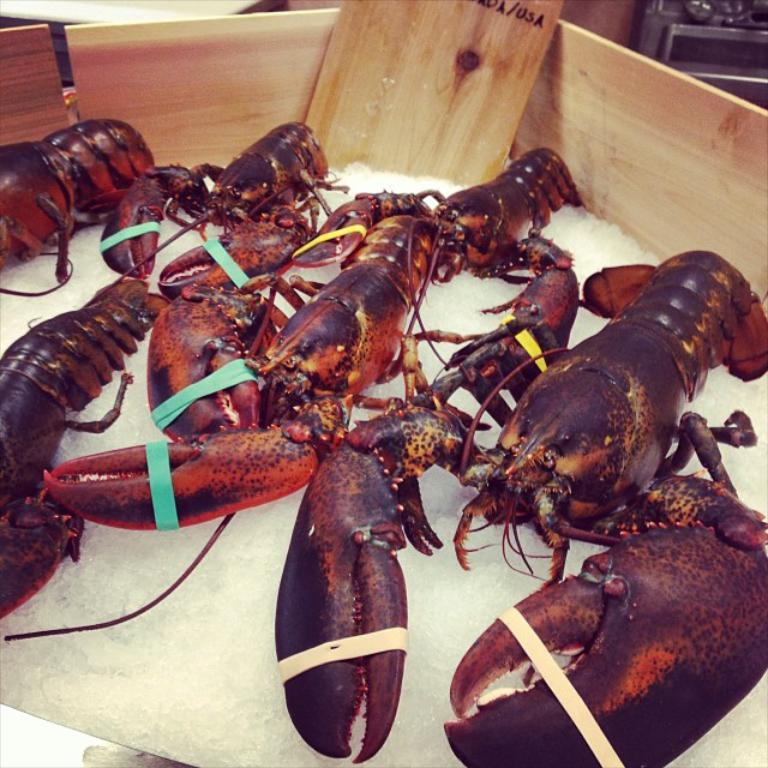What type of seafood is present in the image? There are American lobsters in the image. Where are the lobsters located in the image? The lobsters are in a box. How many apples are visible in the image? There are no apples present in the image; it features American lobsters in a box. What type of assistance is the beggar seeking in the image? There is no beggar present in the image, as it only features American lobsters in a box. 